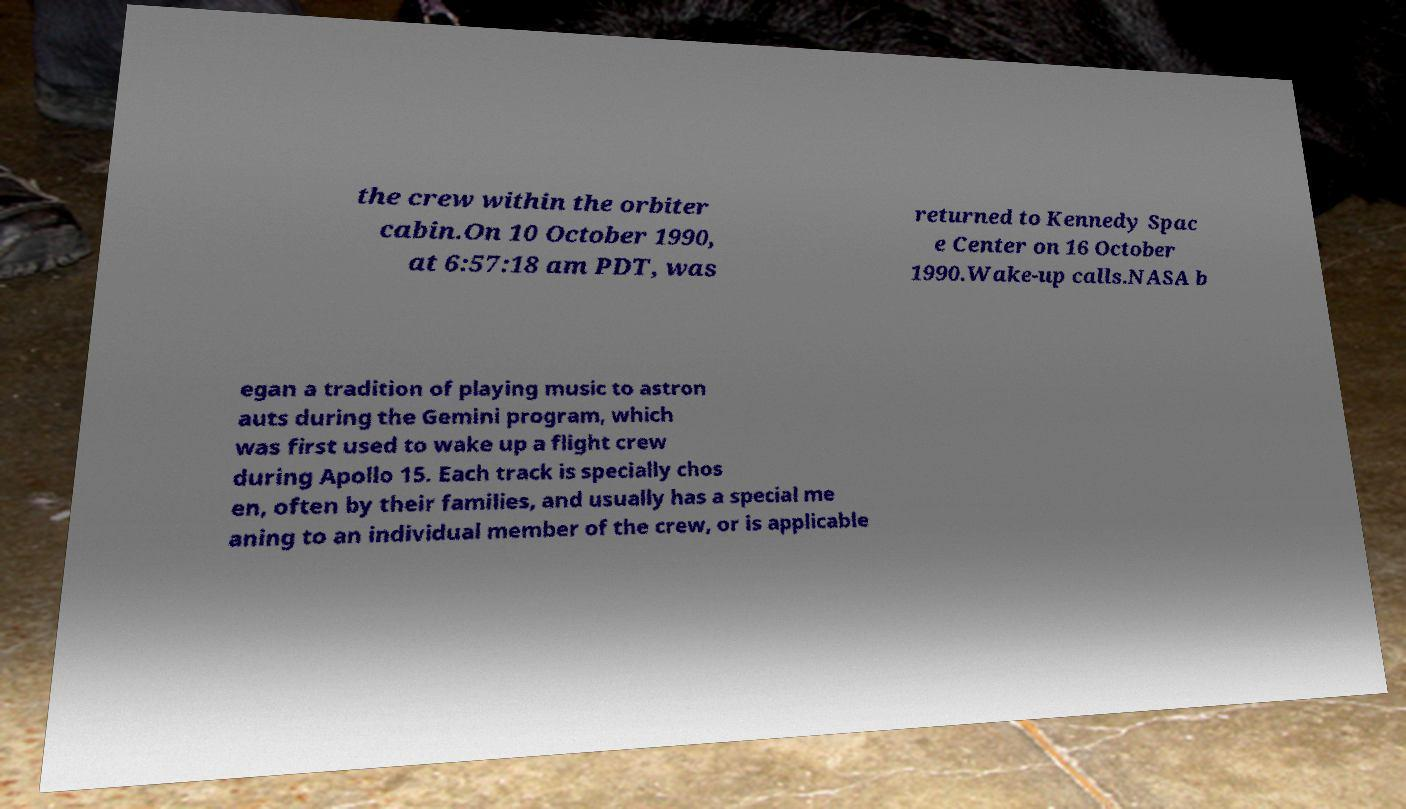Can you read and provide the text displayed in the image?This photo seems to have some interesting text. Can you extract and type it out for me? the crew within the orbiter cabin.On 10 October 1990, at 6:57:18 am PDT, was returned to Kennedy Spac e Center on 16 October 1990.Wake-up calls.NASA b egan a tradition of playing music to astron auts during the Gemini program, which was first used to wake up a flight crew during Apollo 15. Each track is specially chos en, often by their families, and usually has a special me aning to an individual member of the crew, or is applicable 